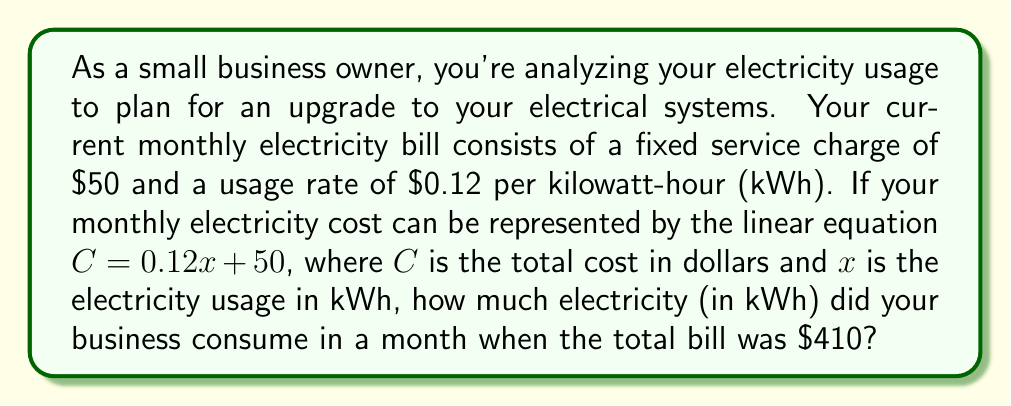Teach me how to tackle this problem. Let's approach this step-by-step using the given linear equation:

1) The equation is in the form $C = 0.12x + 50$, where:
   $C$ = total cost in dollars
   $x$ = electricity usage in kWh
   $0.12$ = cost per kWh
   $50$ = fixed service charge

2) We're told that the total bill was $410, so we can substitute this for $C$:

   $410 = 0.12x + 50$

3) To solve for $x$, we first subtract 50 from both sides:

   $410 - 50 = 0.12x + 50 - 50$
   $360 = 0.12x$

4) Now, divide both sides by 0.12:

   $\frac{360}{0.12} = \frac{0.12x}{0.12}$
   $3000 = x$

5) Therefore, the electricity usage ($x$) was 3000 kWh.

To verify:
$C = 0.12(3000) + 50 = 360 + 50 = 410$

This confirms our solution is correct.
Answer: The business consumed 3000 kWh of electricity in the month when the total bill was $410. 